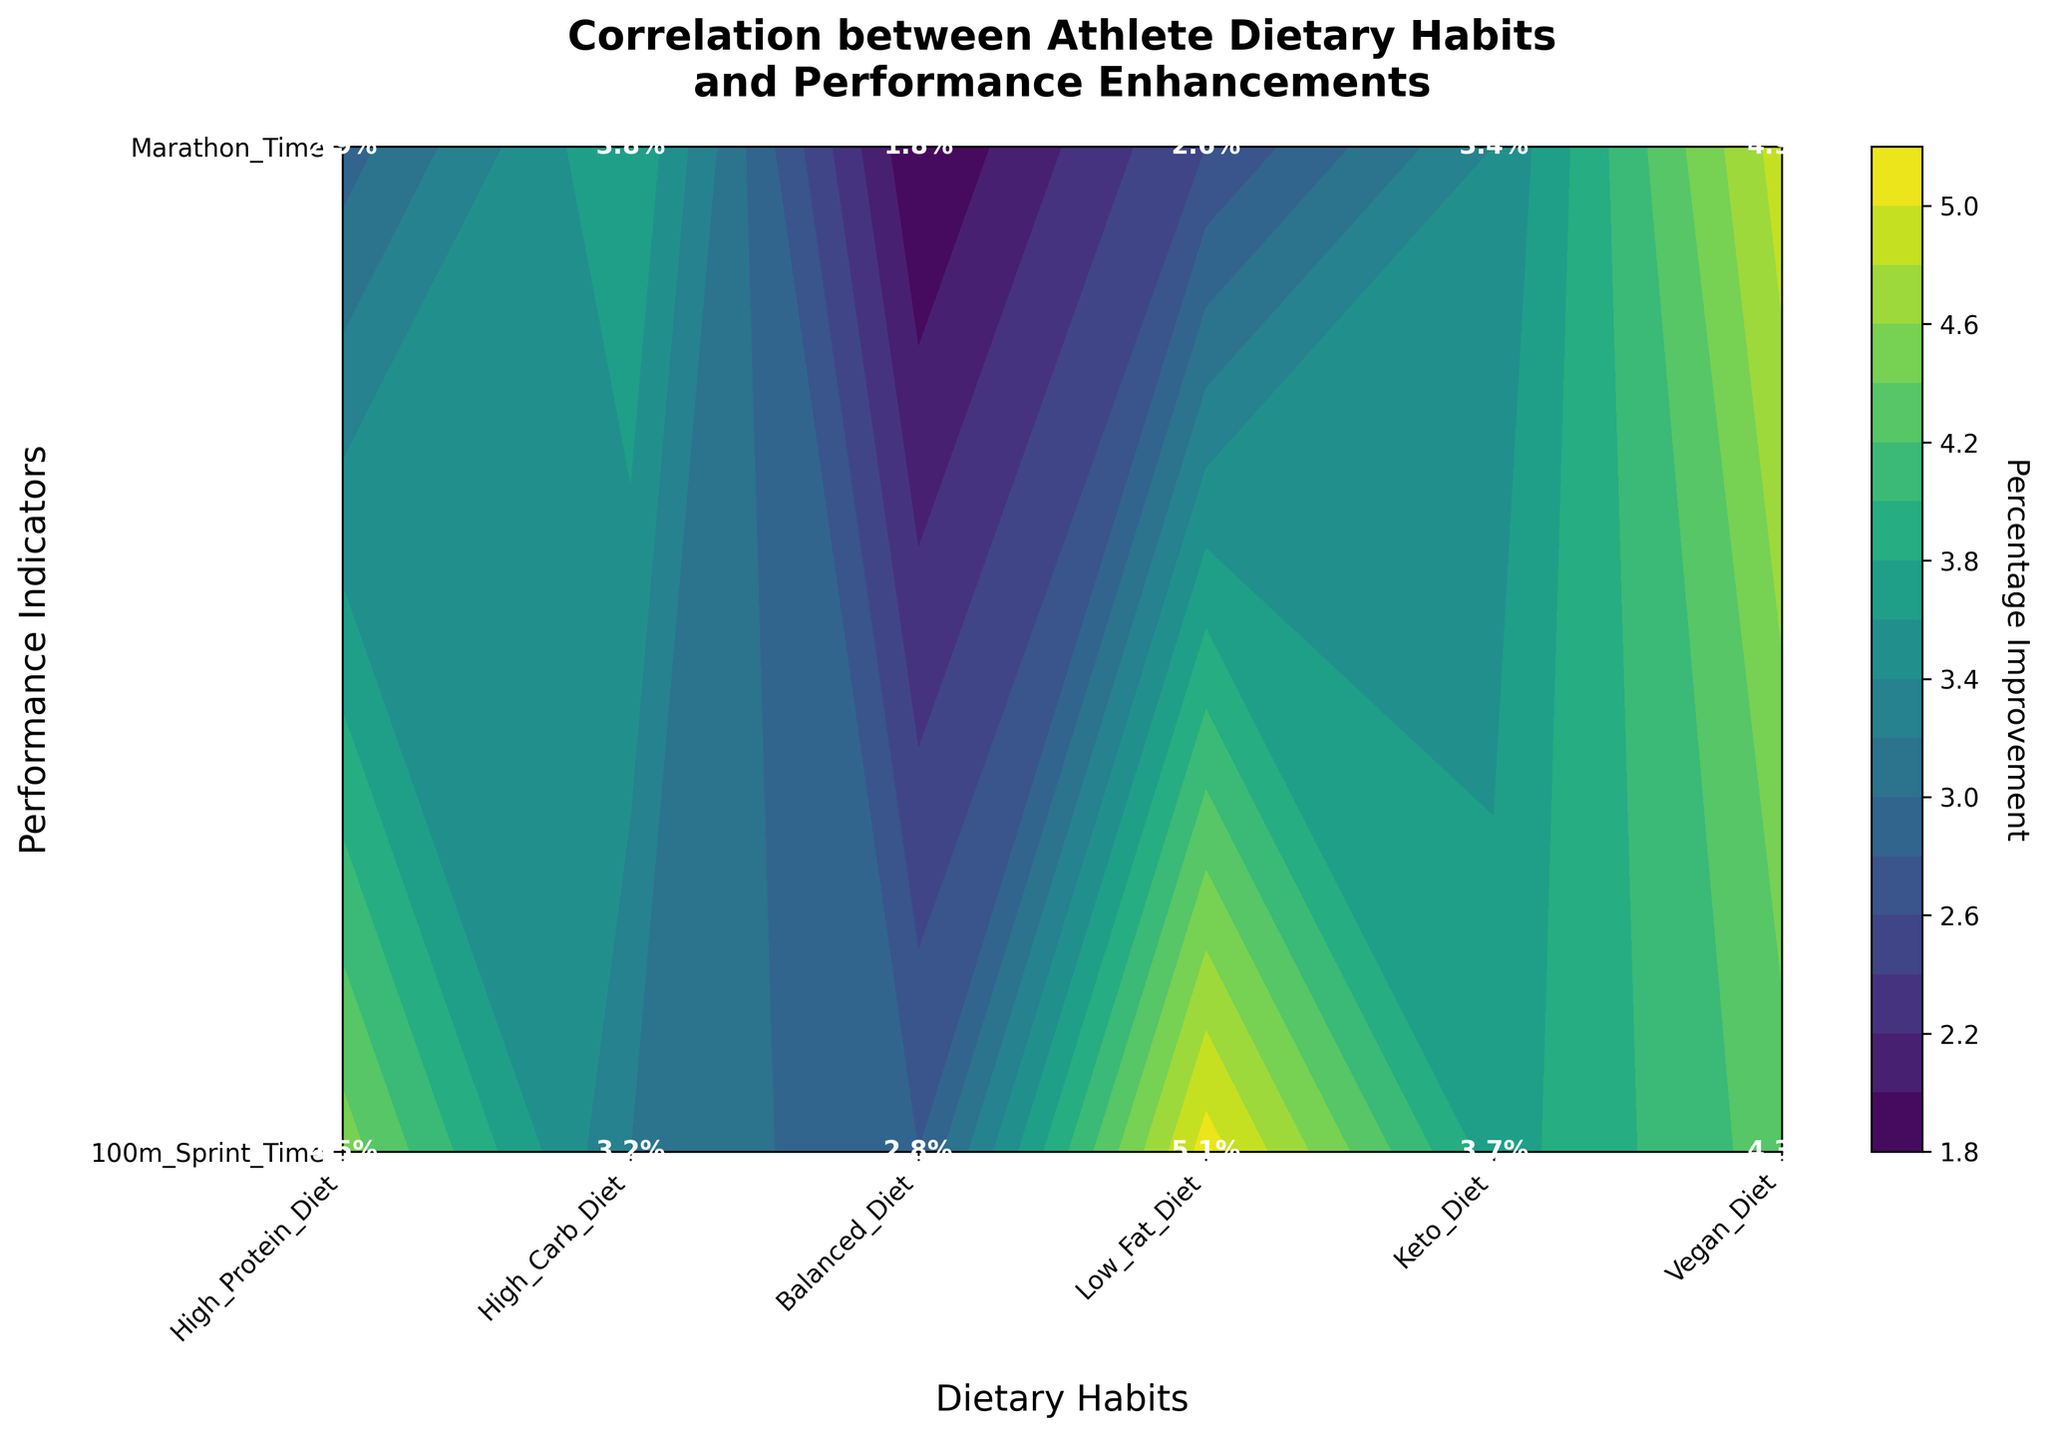What is the title of the plot? The title is located at the top of the plot and is typically prominent and bold to give an overview of what the plot represents.
Answer: Correlation between Athlete Dietary Habits and Performance Enhancements Which dietary habit shows the highest percentage improvement in the marathon performance? Locate the 'Marathon Time' row in the plot and look for the highest percentage value among the dietary habits listed.
Answer: High Carb Diet How much more improvement does a High Protein Diet have compared to a Keto Diet for 100m Sprint Time? Find the percentage improvement for both High Protein Diet and Keto Diet under the '100m Sprint Time' row and calculate the difference. High Protein Diet has 4.5%, and Keto Diet has 1.8%, so the difference is 4.5% - 1.8%.
Answer: 2.7% What is the average percentage improvement for Balanced Diet across both performance indicators? Add the percentage improvements for Balanced Diet in both '100m Sprint Time' and 'Marathon Time' and then divide by 2. The values are 3.7% and 4.3%, so the average is (3.7 + 4.3) / 2.
Answer: 4.0% Which dietary habit has the lowest improvement in 100m Sprint Time? Look for the smallest percentage value in the '100m Sprint Time' row among the dietary habits listed.
Answer: Keto Diet Between a Vegan Diet and a Low Fat Diet, which shows higher improvement in marathon performance and by how much? Locate the values for Vegan Diet and Low Fat Diet under the 'Marathon Time' row and compare them. Vegan Diet has 4.9% and Low Fat Diet has 3.8%, so the difference is 4.9% - 3.8%.
Answer: Vegan Diet by 1.1% What is the overall range of percentage improvements for High Protein Diet across both performance indicators? Identify the maximum and minimum percentage improvements for High Protein Diet in both '100m Sprint Time' and 'Marathon Time', and calculate the range (maximum - minimum). The values are 4.5% and 3.2%, so the range is 4.5% - 3.2%.
Answer: 1.3% If an athlete follows a High Carb Diet, what is the average percentage improvement across the performance indicators? Add the percentage values for High Carb Diet in both '100m Sprint Time' and 'Marathon Time' and then divide by 2. The values are 2.8% and 5.1%, so the average is (2.8 + 5.1) / 2.
Answer: 3.95% Which performance indicator shows greater improvement with a Balanced Diet, and by how much? Compare the values for Balanced Diet in '100m Sprint Time' and 'Marathon Time'. The values are 3.7% and 4.3%, so 'Marathon Time' has greater improvement by 4.3% - 3.7%.
Answer: Marathon Time by 0.6% 